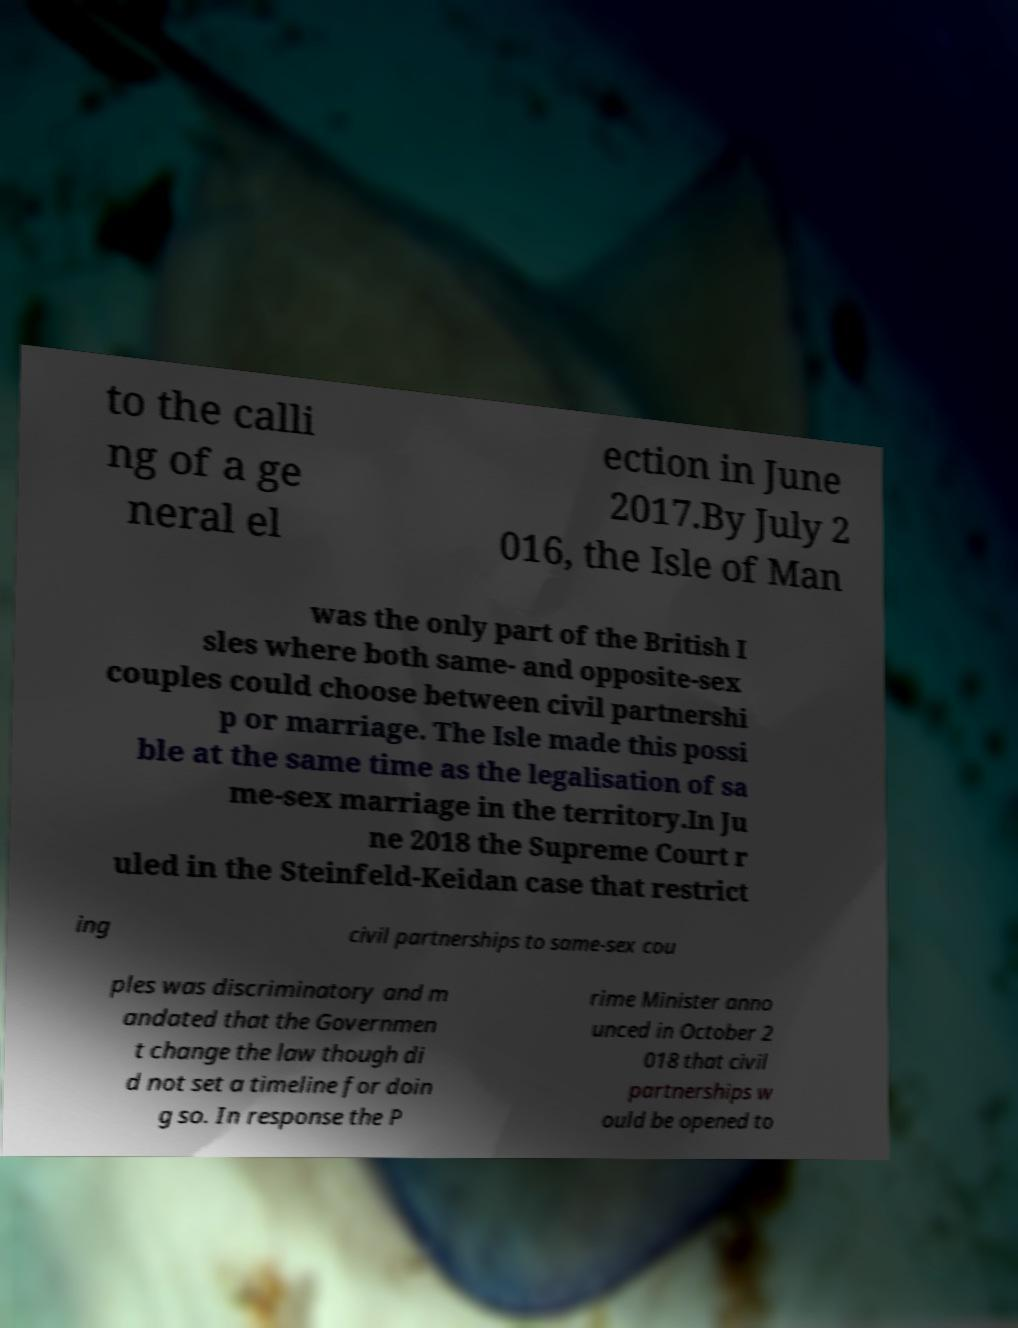For documentation purposes, I need the text within this image transcribed. Could you provide that? to the calli ng of a ge neral el ection in June 2017.By July 2 016, the Isle of Man was the only part of the British I sles where both same- and opposite-sex couples could choose between civil partnershi p or marriage. The Isle made this possi ble at the same time as the legalisation of sa me-sex marriage in the territory.In Ju ne 2018 the Supreme Court r uled in the Steinfeld-Keidan case that restrict ing civil partnerships to same-sex cou ples was discriminatory and m andated that the Governmen t change the law though di d not set a timeline for doin g so. In response the P rime Minister anno unced in October 2 018 that civil partnerships w ould be opened to 